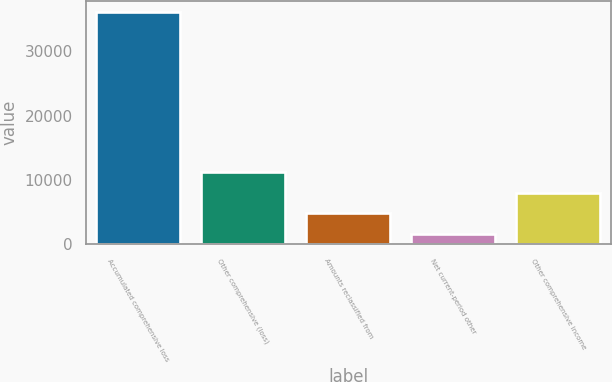<chart> <loc_0><loc_0><loc_500><loc_500><bar_chart><fcel>Accumulated comprehensive loss<fcel>Other comprehensive (loss)<fcel>Amounts reclassified from<fcel>Net current-period other<fcel>Other comprehensive income<nl><fcel>36056<fcel>11245<fcel>4839<fcel>1636<fcel>8042<nl></chart> 